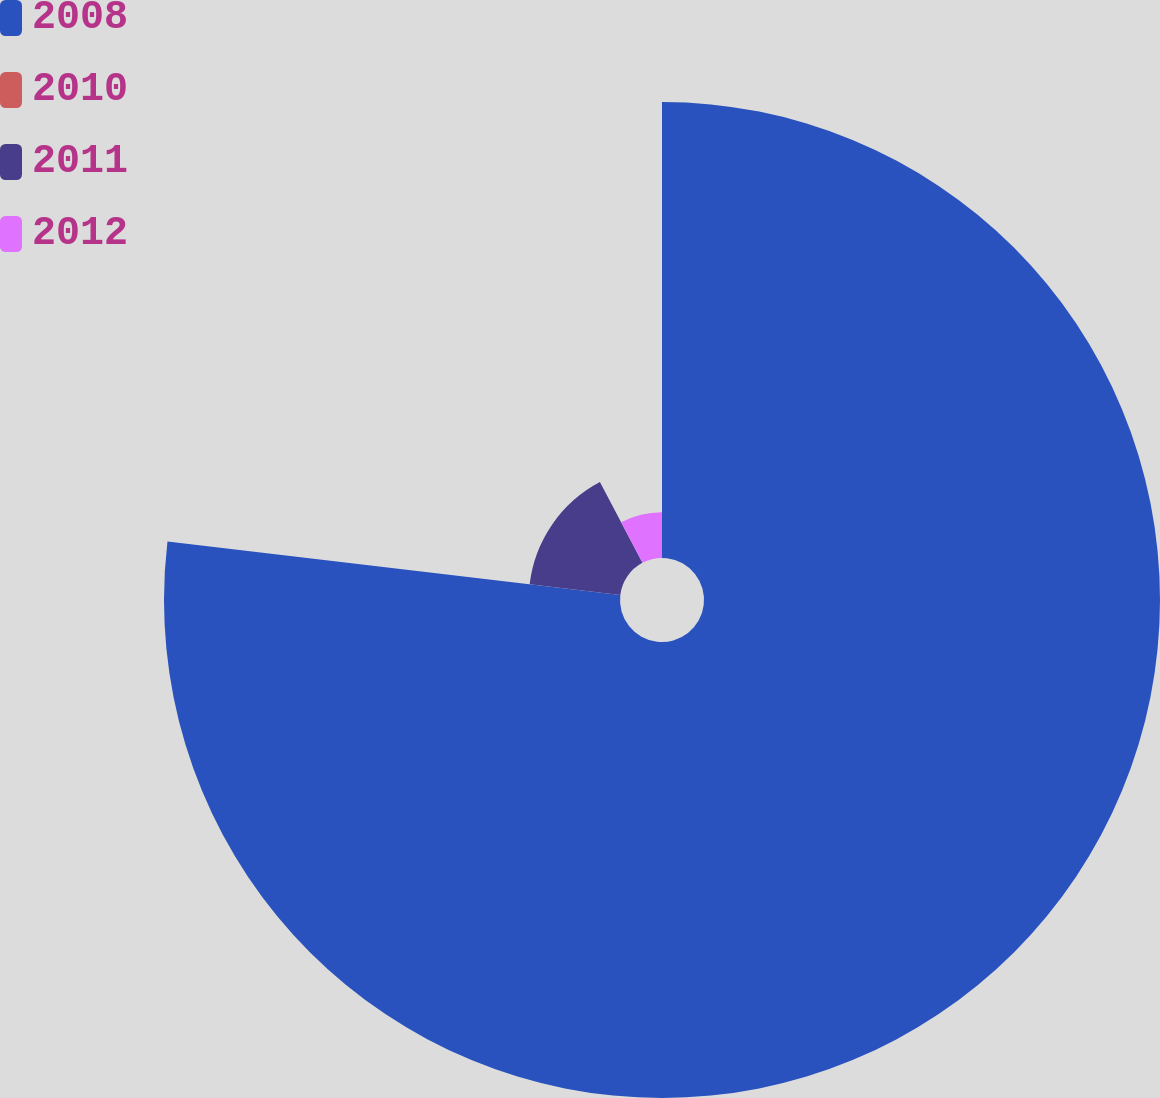Convert chart to OTSL. <chart><loc_0><loc_0><loc_500><loc_500><pie_chart><fcel>2008<fcel>2010<fcel>2011<fcel>2012<nl><fcel>76.87%<fcel>0.02%<fcel>15.39%<fcel>7.71%<nl></chart> 